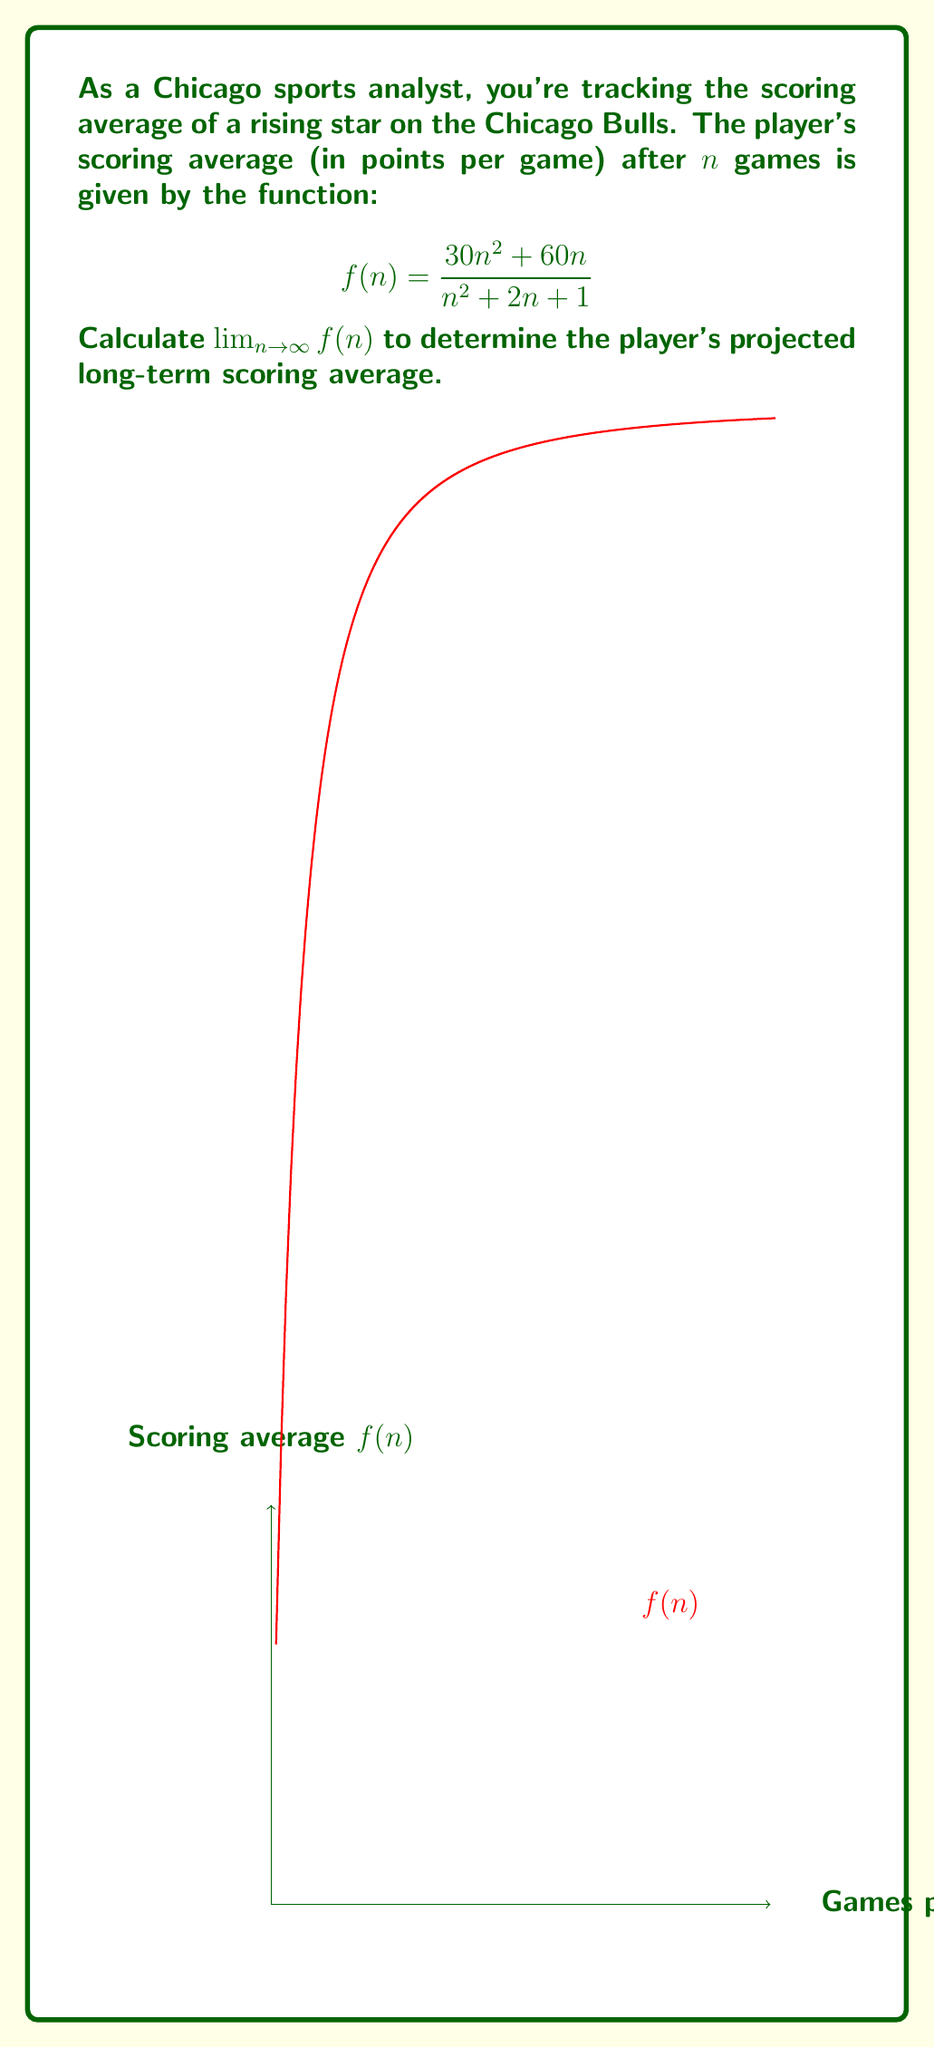Give your solution to this math problem. To find $\lim_{n \to \infty} f(n)$, we'll follow these steps:

1) First, let's examine the degree of the numerator and denominator:
   Numerator: $30n^2 + 60n$ (degree 2)
   Denominator: $n^2 + 2n + 1$ (degree 2)

2) Since both have the same degree, we can find the limit by comparing the coefficients of the highest degree terms:

   $$\lim_{n \to \infty} f(n) = \lim_{n \to \infty} \frac{30n^2 + 60n}{n^2 + 2n + 1} = \frac{30}{1} = 30$$

3) To verify, we can use the division method:

   $$\frac{30n^2 + 60n}{n^2 + 2n + 1} = \frac{30n^2 + 60n + 30 - 30}{n^2 + 2n + 1}$$

   $$= \frac{30(n^2 + 2n + 1) - 30}{n^2 + 2n + 1} = 30 - \frac{30}{n^2 + 2n + 1}$$

4) As $n$ approaches infinity, $\frac{30}{n^2 + 2n + 1}$ approaches 0:

   $$\lim_{n \to \infty} \left(30 - \frac{30}{n^2 + 2n + 1}\right) = 30 - 0 = 30$$

Therefore, the player's projected long-term scoring average is 30 points per game.
Answer: 30 points per game 